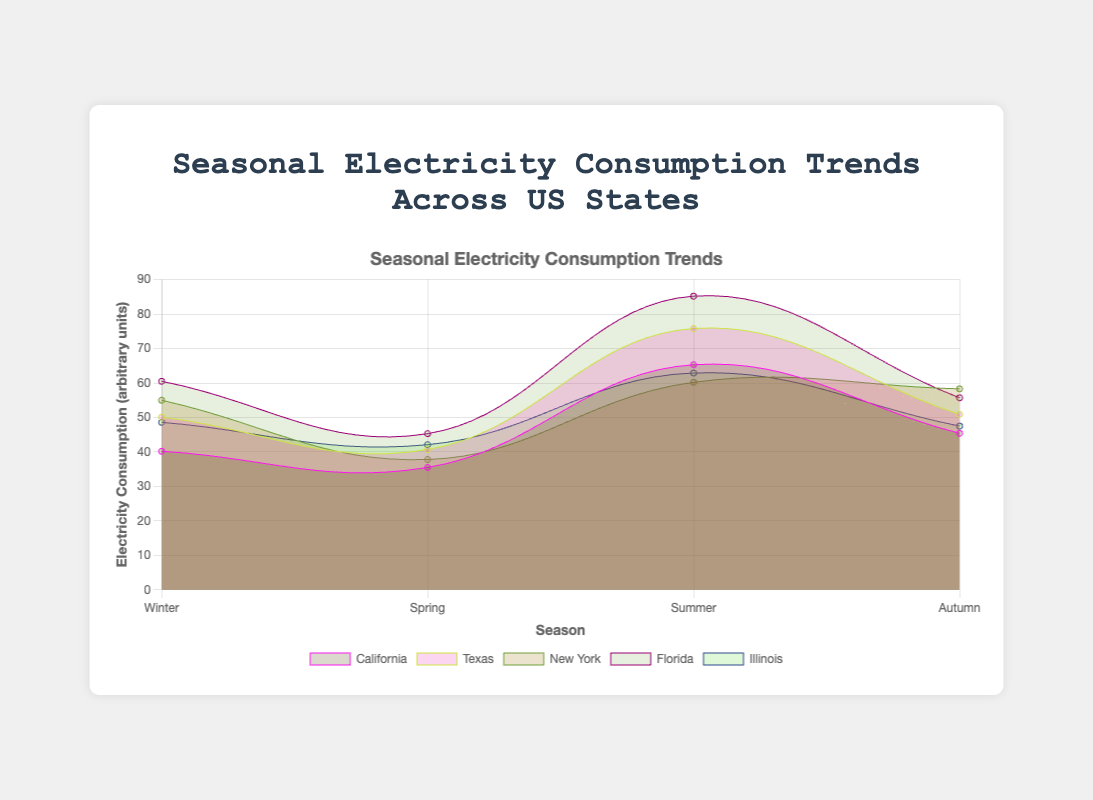What is the title of the chart? The title is typically located at the top of the chart. Looking at the visual, the title clearly states "Seasonal Electricity Consumption Trends Across US States".
Answer: Seasonal Electricity Consumption Trends Across US States Which state has the highest electricity consumption in the summer? By observing the data points for each state on the x-axis labeled as 'Summer' and comparing them, Florida shows the highest value. Florida's consumption in summer is 85.2, which is higher than the summer values for all other states.
Answer: Florida What is the average electricity consumption for New York across all seasons? The values for New York across seasons are Winter (55.0), Spring (37.8), Summer (60.2), and Autumn (58.3). Summing these values results in 211.3. Dividing by 4 gives the average: 211.3/4 = 52.825.
Answer: 52.825 Which seasons show an increase in electricity consumption for Illinois from Spring to Autumn? We need to examine the data points for Illinois from Spring (42.1) to Summer (62.9) to Autumn (47.5). This analysis shows an increase from Spring to Summer and a decrease from Summer to Autumn. Thus, the increase is observed in the transition from Spring to Summer.
Answer: Spring to Summer How does winter electricity consumption in California compare with that in Texas? We compare the winter values for California (40.2) and Texas (50.1). By subtraction, 50.1 - 40.2 = 9.9, showing that Texas has higher winter consumption by 9.9 units than California.
Answer: Texas is 9.9 units higher What is the total electricity consumption for Florida across all seasons? Summing up Florida’s seasonal consumption values: Winter (60.5), Spring (45.3), Summer (85.2), and Autumn (55.7) results in the total: 60.5 + 45.3 + 85.2 + 55.7 = 246.7.
Answer: 246.7 What trend can be observed in summer electricity consumption across the states? Observing the 'Summer' data points, they generally exhibit the highest values compared to other seasons for each state. The trend shows increased electricity usage during summer, with the highest being in Florida (85.2), followed by Texas (75.8), California (65.3), Illinois (62.9), and New York (60.2).
Answer: Higher consumption in Summer for all states Which state shows the most consistent electricity consumption across all seasons? We need to find the state with the smallest variation in consumption values across seasons. For this, we can observe the data spread for each state. New York has the most consistent range: Winter (55.0), Spring (37.8), Summer (60.2), and Autumn (58.3), where the range difference is lowest compared to other states.
Answer: New York What is the difference between electricity consumption in Winter and Summer for Texas? For Texas, the Winter value is 50.1 and the Summer value is 75.8. The difference is obtained by subtracting these values: 75.8 - 50.1 = 25.7.
Answer: 25.7 How do the electricity consumption patterns in California and Illinois compare across seasons? By comparing seasonal values, we see: 
    - Winter: California (40.2), Illinois (48.6)
    - Spring: California (35.5), Illinois (42.1)
    - Summer: California (65.3), Illinois (62.9)
    - Autumn: California (45.4), Illinois (47.5)
Both states have increased consumption during summer and lower during spring. Illinois generally has slightly higher values across seasons except summer where California is marginally higher.
Answer: Illinois marginally higher except in Summer 